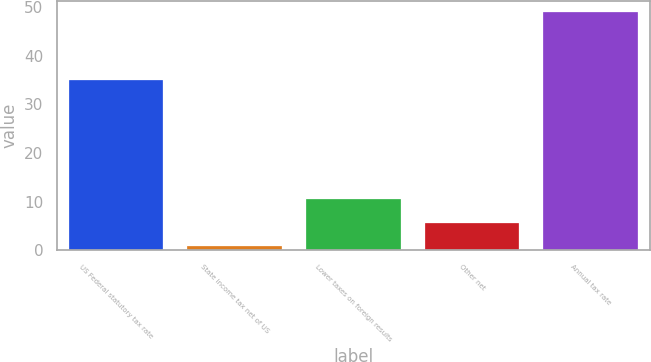<chart> <loc_0><loc_0><loc_500><loc_500><bar_chart><fcel>US Federal statutory tax rate<fcel>State income tax net of US<fcel>Lower taxes on foreign results<fcel>Other net<fcel>Annual tax rate<nl><fcel>35<fcel>0.9<fcel>10.5<fcel>5.7<fcel>48.9<nl></chart> 